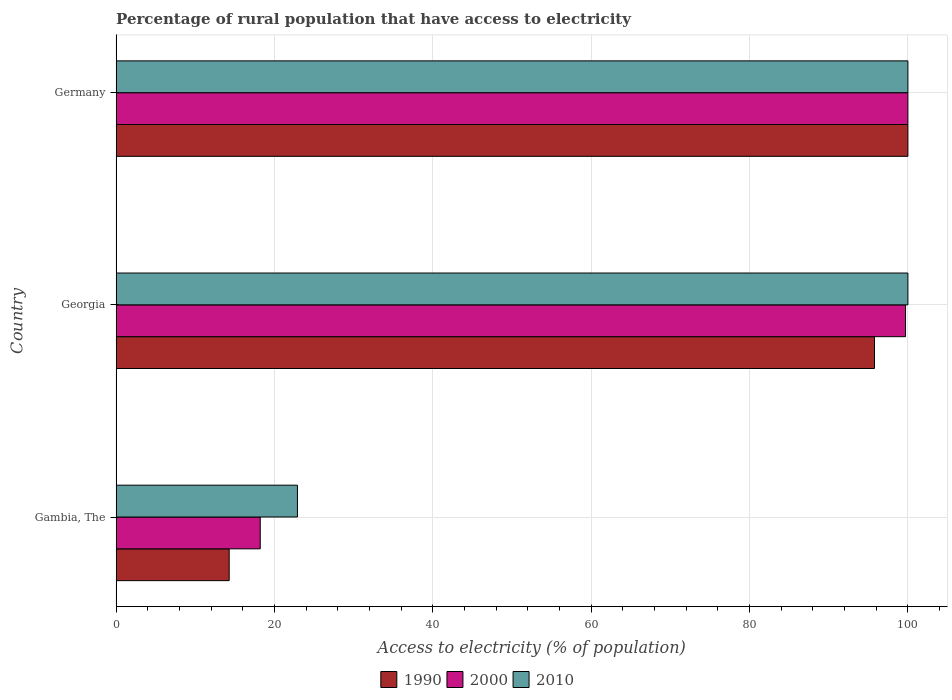How many groups of bars are there?
Offer a terse response. 3. What is the label of the 3rd group of bars from the top?
Provide a short and direct response. Gambia, The. What is the percentage of rural population that have access to electricity in 2010 in Gambia, The?
Provide a succinct answer. 22.9. Across all countries, what is the maximum percentage of rural population that have access to electricity in 2000?
Make the answer very short. 100. Across all countries, what is the minimum percentage of rural population that have access to electricity in 2010?
Your answer should be compact. 22.9. In which country was the percentage of rural population that have access to electricity in 2000 minimum?
Your answer should be compact. Gambia, The. What is the total percentage of rural population that have access to electricity in 2010 in the graph?
Give a very brief answer. 222.9. What is the difference between the percentage of rural population that have access to electricity in 2000 in Gambia, The and that in Georgia?
Your answer should be compact. -81.5. What is the difference between the percentage of rural population that have access to electricity in 2010 in Gambia, The and the percentage of rural population that have access to electricity in 2000 in Germany?
Your response must be concise. -77.1. What is the average percentage of rural population that have access to electricity in 1990 per country?
Your answer should be compact. 70.02. What is the difference between the percentage of rural population that have access to electricity in 1990 and percentage of rural population that have access to electricity in 2010 in Georgia?
Provide a succinct answer. -4.22. In how many countries, is the percentage of rural population that have access to electricity in 2010 greater than 32 %?
Your response must be concise. 2. Is the percentage of rural population that have access to electricity in 2000 in Georgia less than that in Germany?
Offer a very short reply. Yes. Is the difference between the percentage of rural population that have access to electricity in 1990 in Gambia, The and Georgia greater than the difference between the percentage of rural population that have access to electricity in 2010 in Gambia, The and Georgia?
Your response must be concise. No. What is the difference between the highest and the second highest percentage of rural population that have access to electricity in 1990?
Make the answer very short. 4.22. What is the difference between the highest and the lowest percentage of rural population that have access to electricity in 2000?
Ensure brevity in your answer.  81.8. Is the sum of the percentage of rural population that have access to electricity in 2010 in Gambia, The and Germany greater than the maximum percentage of rural population that have access to electricity in 2000 across all countries?
Make the answer very short. Yes. What does the 1st bar from the bottom in Gambia, The represents?
Give a very brief answer. 1990. Is it the case that in every country, the sum of the percentage of rural population that have access to electricity in 1990 and percentage of rural population that have access to electricity in 2010 is greater than the percentage of rural population that have access to electricity in 2000?
Your response must be concise. Yes. How many countries are there in the graph?
Give a very brief answer. 3. What is the difference between two consecutive major ticks on the X-axis?
Provide a short and direct response. 20. Are the values on the major ticks of X-axis written in scientific E-notation?
Provide a succinct answer. No. Does the graph contain any zero values?
Provide a short and direct response. No. How many legend labels are there?
Make the answer very short. 3. What is the title of the graph?
Keep it short and to the point. Percentage of rural population that have access to electricity. What is the label or title of the X-axis?
Your answer should be very brief. Access to electricity (% of population). What is the Access to electricity (% of population) in 1990 in Gambia, The?
Your answer should be very brief. 14.28. What is the Access to electricity (% of population) of 2010 in Gambia, The?
Provide a succinct answer. 22.9. What is the Access to electricity (% of population) in 1990 in Georgia?
Your answer should be very brief. 95.78. What is the Access to electricity (% of population) of 2000 in Georgia?
Your answer should be very brief. 99.7. What is the Access to electricity (% of population) of 2010 in Georgia?
Ensure brevity in your answer.  100. What is the Access to electricity (% of population) of 1990 in Germany?
Make the answer very short. 100. What is the Access to electricity (% of population) of 2000 in Germany?
Give a very brief answer. 100. Across all countries, what is the maximum Access to electricity (% of population) in 1990?
Provide a succinct answer. 100. Across all countries, what is the maximum Access to electricity (% of population) of 2010?
Provide a succinct answer. 100. Across all countries, what is the minimum Access to electricity (% of population) of 1990?
Offer a very short reply. 14.28. Across all countries, what is the minimum Access to electricity (% of population) of 2000?
Provide a short and direct response. 18.2. Across all countries, what is the minimum Access to electricity (% of population) of 2010?
Your answer should be compact. 22.9. What is the total Access to electricity (% of population) of 1990 in the graph?
Keep it short and to the point. 210.06. What is the total Access to electricity (% of population) of 2000 in the graph?
Provide a succinct answer. 217.9. What is the total Access to electricity (% of population) in 2010 in the graph?
Ensure brevity in your answer.  222.9. What is the difference between the Access to electricity (% of population) of 1990 in Gambia, The and that in Georgia?
Your answer should be compact. -81.5. What is the difference between the Access to electricity (% of population) of 2000 in Gambia, The and that in Georgia?
Offer a terse response. -81.5. What is the difference between the Access to electricity (% of population) of 2010 in Gambia, The and that in Georgia?
Provide a short and direct response. -77.1. What is the difference between the Access to electricity (% of population) of 1990 in Gambia, The and that in Germany?
Your answer should be very brief. -85.72. What is the difference between the Access to electricity (% of population) in 2000 in Gambia, The and that in Germany?
Provide a succinct answer. -81.8. What is the difference between the Access to electricity (% of population) in 2010 in Gambia, The and that in Germany?
Provide a short and direct response. -77.1. What is the difference between the Access to electricity (% of population) in 1990 in Georgia and that in Germany?
Provide a short and direct response. -4.22. What is the difference between the Access to electricity (% of population) in 2010 in Georgia and that in Germany?
Provide a short and direct response. 0. What is the difference between the Access to electricity (% of population) in 1990 in Gambia, The and the Access to electricity (% of population) in 2000 in Georgia?
Your answer should be compact. -85.42. What is the difference between the Access to electricity (% of population) in 1990 in Gambia, The and the Access to electricity (% of population) in 2010 in Georgia?
Make the answer very short. -85.72. What is the difference between the Access to electricity (% of population) of 2000 in Gambia, The and the Access to electricity (% of population) of 2010 in Georgia?
Your answer should be very brief. -81.8. What is the difference between the Access to electricity (% of population) in 1990 in Gambia, The and the Access to electricity (% of population) in 2000 in Germany?
Offer a very short reply. -85.72. What is the difference between the Access to electricity (% of population) of 1990 in Gambia, The and the Access to electricity (% of population) of 2010 in Germany?
Ensure brevity in your answer.  -85.72. What is the difference between the Access to electricity (% of population) in 2000 in Gambia, The and the Access to electricity (% of population) in 2010 in Germany?
Offer a very short reply. -81.8. What is the difference between the Access to electricity (% of population) in 1990 in Georgia and the Access to electricity (% of population) in 2000 in Germany?
Make the answer very short. -4.22. What is the difference between the Access to electricity (% of population) of 1990 in Georgia and the Access to electricity (% of population) of 2010 in Germany?
Offer a very short reply. -4.22. What is the average Access to electricity (% of population) of 1990 per country?
Your answer should be compact. 70.02. What is the average Access to electricity (% of population) in 2000 per country?
Provide a succinct answer. 72.63. What is the average Access to electricity (% of population) of 2010 per country?
Offer a very short reply. 74.3. What is the difference between the Access to electricity (% of population) in 1990 and Access to electricity (% of population) in 2000 in Gambia, The?
Make the answer very short. -3.92. What is the difference between the Access to electricity (% of population) in 1990 and Access to electricity (% of population) in 2010 in Gambia, The?
Your answer should be very brief. -8.62. What is the difference between the Access to electricity (% of population) of 2000 and Access to electricity (% of population) of 2010 in Gambia, The?
Give a very brief answer. -4.7. What is the difference between the Access to electricity (% of population) of 1990 and Access to electricity (% of population) of 2000 in Georgia?
Keep it short and to the point. -3.92. What is the difference between the Access to electricity (% of population) of 1990 and Access to electricity (% of population) of 2010 in Georgia?
Make the answer very short. -4.22. What is the difference between the Access to electricity (% of population) in 1990 and Access to electricity (% of population) in 2000 in Germany?
Make the answer very short. 0. What is the difference between the Access to electricity (% of population) in 1990 and Access to electricity (% of population) in 2010 in Germany?
Your answer should be compact. 0. What is the difference between the Access to electricity (% of population) in 2000 and Access to electricity (% of population) in 2010 in Germany?
Keep it short and to the point. 0. What is the ratio of the Access to electricity (% of population) in 1990 in Gambia, The to that in Georgia?
Provide a short and direct response. 0.15. What is the ratio of the Access to electricity (% of population) of 2000 in Gambia, The to that in Georgia?
Keep it short and to the point. 0.18. What is the ratio of the Access to electricity (% of population) in 2010 in Gambia, The to that in Georgia?
Offer a very short reply. 0.23. What is the ratio of the Access to electricity (% of population) in 1990 in Gambia, The to that in Germany?
Offer a very short reply. 0.14. What is the ratio of the Access to electricity (% of population) in 2000 in Gambia, The to that in Germany?
Your answer should be very brief. 0.18. What is the ratio of the Access to electricity (% of population) in 2010 in Gambia, The to that in Germany?
Make the answer very short. 0.23. What is the ratio of the Access to electricity (% of population) in 1990 in Georgia to that in Germany?
Your answer should be very brief. 0.96. What is the ratio of the Access to electricity (% of population) of 2000 in Georgia to that in Germany?
Offer a terse response. 1. What is the difference between the highest and the second highest Access to electricity (% of population) in 1990?
Your response must be concise. 4.22. What is the difference between the highest and the second highest Access to electricity (% of population) in 2010?
Your response must be concise. 0. What is the difference between the highest and the lowest Access to electricity (% of population) of 1990?
Offer a terse response. 85.72. What is the difference between the highest and the lowest Access to electricity (% of population) in 2000?
Provide a short and direct response. 81.8. What is the difference between the highest and the lowest Access to electricity (% of population) in 2010?
Offer a very short reply. 77.1. 